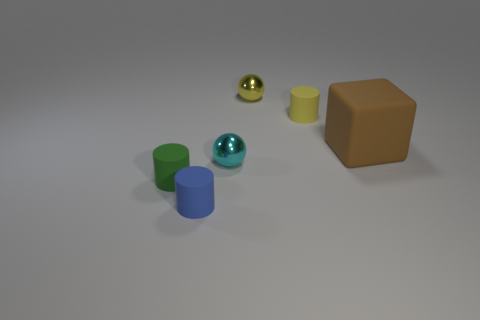What is the material of the cyan object that is the same shape as the tiny yellow metallic thing?
Offer a terse response. Metal. There is a thing that is left of the yellow matte cylinder and behind the brown object; what material is it made of?
Your answer should be compact. Metal. What number of small yellow metal things have the same shape as the cyan shiny thing?
Keep it short and to the point. 1. There is a small sphere that is in front of the small rubber object that is on the right side of the cyan object; what color is it?
Offer a very short reply. Cyan. Are there the same number of blue cylinders that are to the right of the big cube and tiny metallic objects?
Offer a terse response. No. Are there any gray shiny cylinders that have the same size as the blue rubber thing?
Provide a succinct answer. No. There is a brown thing; is its size the same as the cylinder on the left side of the blue thing?
Your answer should be very brief. No. Are there an equal number of small blue cylinders behind the green matte thing and rubber cylinders to the left of the yellow metal ball?
Make the answer very short. No. What material is the tiny object to the left of the blue matte cylinder?
Offer a very short reply. Rubber. Do the cyan metallic thing and the blue matte cylinder have the same size?
Keep it short and to the point. Yes. 